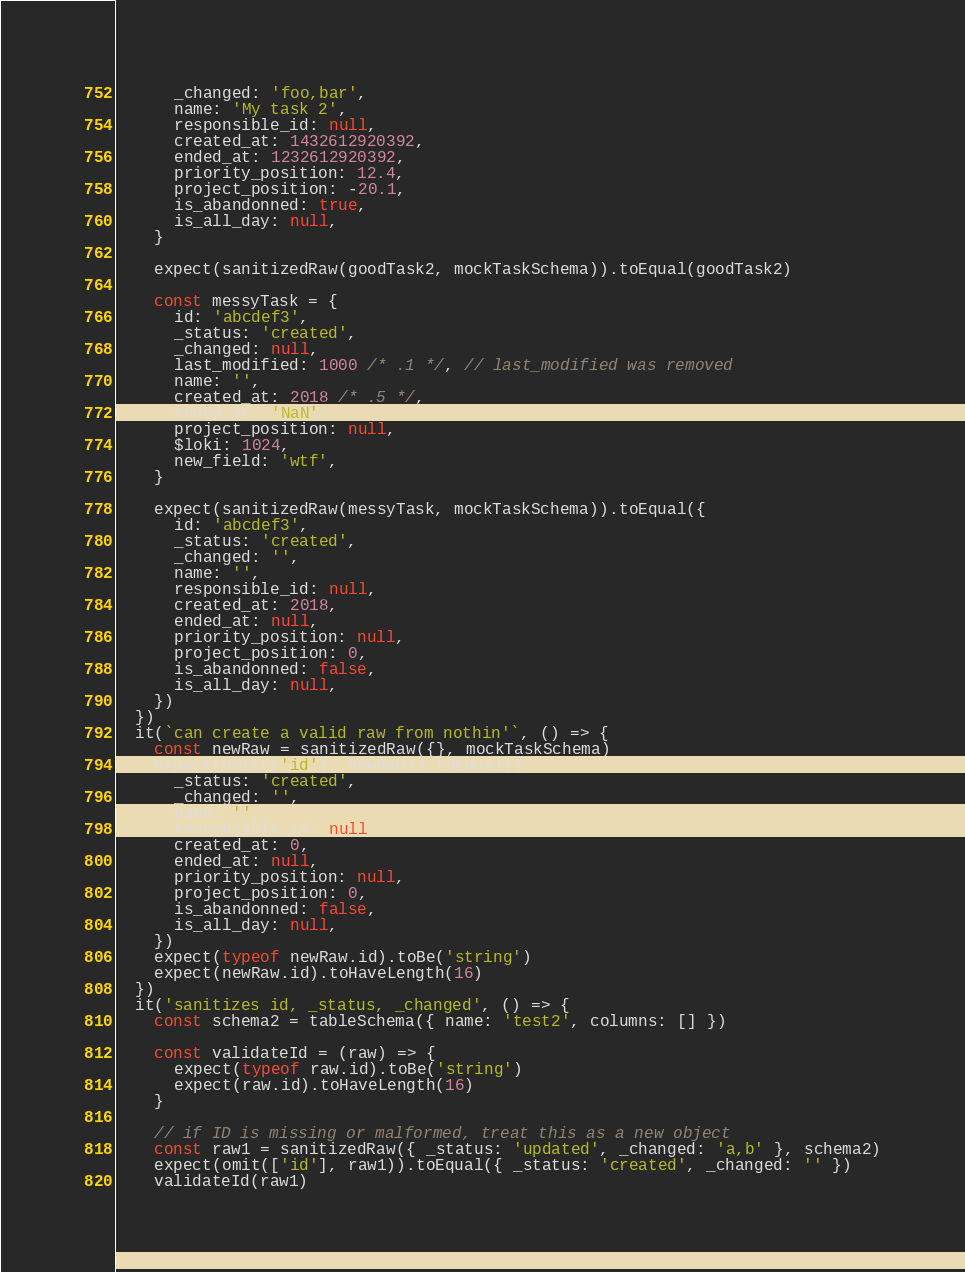Convert code to text. <code><loc_0><loc_0><loc_500><loc_500><_JavaScript_>      _changed: 'foo,bar',
      name: 'My task 2',
      responsible_id: null,
      created_at: 1432612920392,
      ended_at: 1232612920392,
      priority_position: 12.4,
      project_position: -20.1,
      is_abandonned: true,
      is_all_day: null,
    }

    expect(sanitizedRaw(goodTask2, mockTaskSchema)).toEqual(goodTask2)

    const messyTask = {
      id: 'abcdef3',
      _status: 'created',
      _changed: null,
      last_modified: 1000 /* .1 */, // last_modified was removed
      name: '',
      created_at: 2018 /* .5 */,
      ended_at: 'NaN',
      project_position: null,
      $loki: 1024,
      new_field: 'wtf',
    }

    expect(sanitizedRaw(messyTask, mockTaskSchema)).toEqual({
      id: 'abcdef3',
      _status: 'created',
      _changed: '',
      name: '',
      responsible_id: null,
      created_at: 2018,
      ended_at: null,
      priority_position: null,
      project_position: 0,
      is_abandonned: false,
      is_all_day: null,
    })
  })
  it(`can create a valid raw from nothin'`, () => {
    const newRaw = sanitizedRaw({}, mockTaskSchema)
    expect(omit(['id'], newRaw)).toEqual({
      _status: 'created',
      _changed: '',
      name: '',
      responsible_id: null,
      created_at: 0,
      ended_at: null,
      priority_position: null,
      project_position: 0,
      is_abandonned: false,
      is_all_day: null,
    })
    expect(typeof newRaw.id).toBe('string')
    expect(newRaw.id).toHaveLength(16)
  })
  it('sanitizes id, _status, _changed', () => {
    const schema2 = tableSchema({ name: 'test2', columns: [] })

    const validateId = (raw) => {
      expect(typeof raw.id).toBe('string')
      expect(raw.id).toHaveLength(16)
    }

    // if ID is missing or malformed, treat this as a new object
    const raw1 = sanitizedRaw({ _status: 'updated', _changed: 'a,b' }, schema2)
    expect(omit(['id'], raw1)).toEqual({ _status: 'created', _changed: '' })
    validateId(raw1)
</code> 